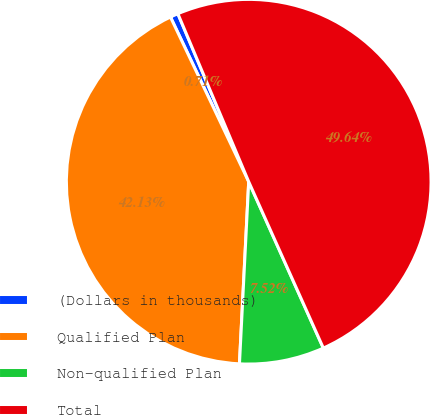<chart> <loc_0><loc_0><loc_500><loc_500><pie_chart><fcel>(Dollars in thousands)<fcel>Qualified Plan<fcel>Non-qualified Plan<fcel>Total<nl><fcel>0.71%<fcel>42.13%<fcel>7.52%<fcel>49.64%<nl></chart> 